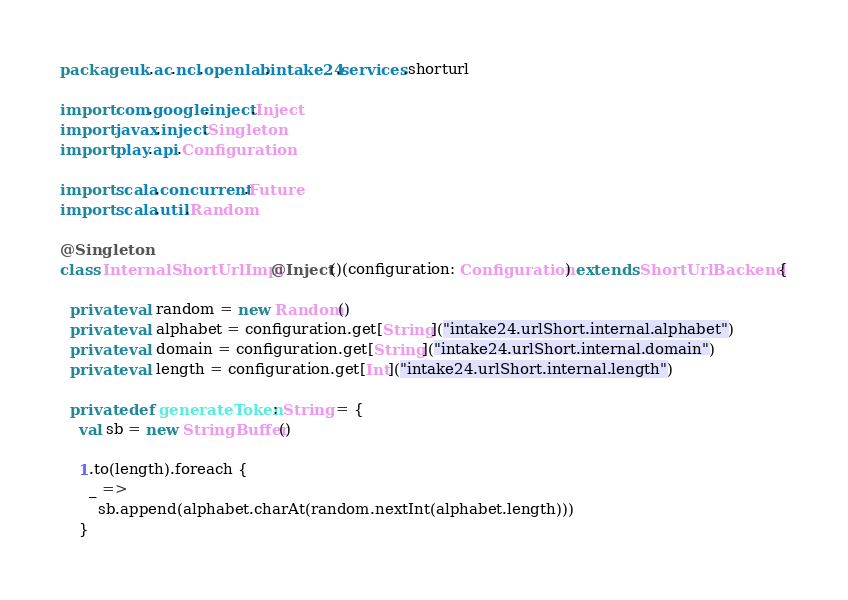<code> <loc_0><loc_0><loc_500><loc_500><_Scala_>package uk.ac.ncl.openlab.intake24.services.shorturl

import com.google.inject.Inject
import javax.inject.Singleton
import play.api.Configuration

import scala.concurrent.Future
import scala.util.Random

@Singleton
class InternalShortUrlImpl @Inject()(configuration: Configuration) extends ShortUrlBackend {

  private val random = new Random()
  private val alphabet = configuration.get[String]("intake24.urlShort.internal.alphabet")
  private val domain = configuration.get[String]("intake24.urlShort.internal.domain")
  private val length = configuration.get[Int]("intake24.urlShort.internal.length")

  private def generateToken: String = {
    val sb = new StringBuffer()

    1.to(length).foreach {
      _ =>
        sb.append(alphabet.charAt(random.nextInt(alphabet.length)))
    }
</code> 